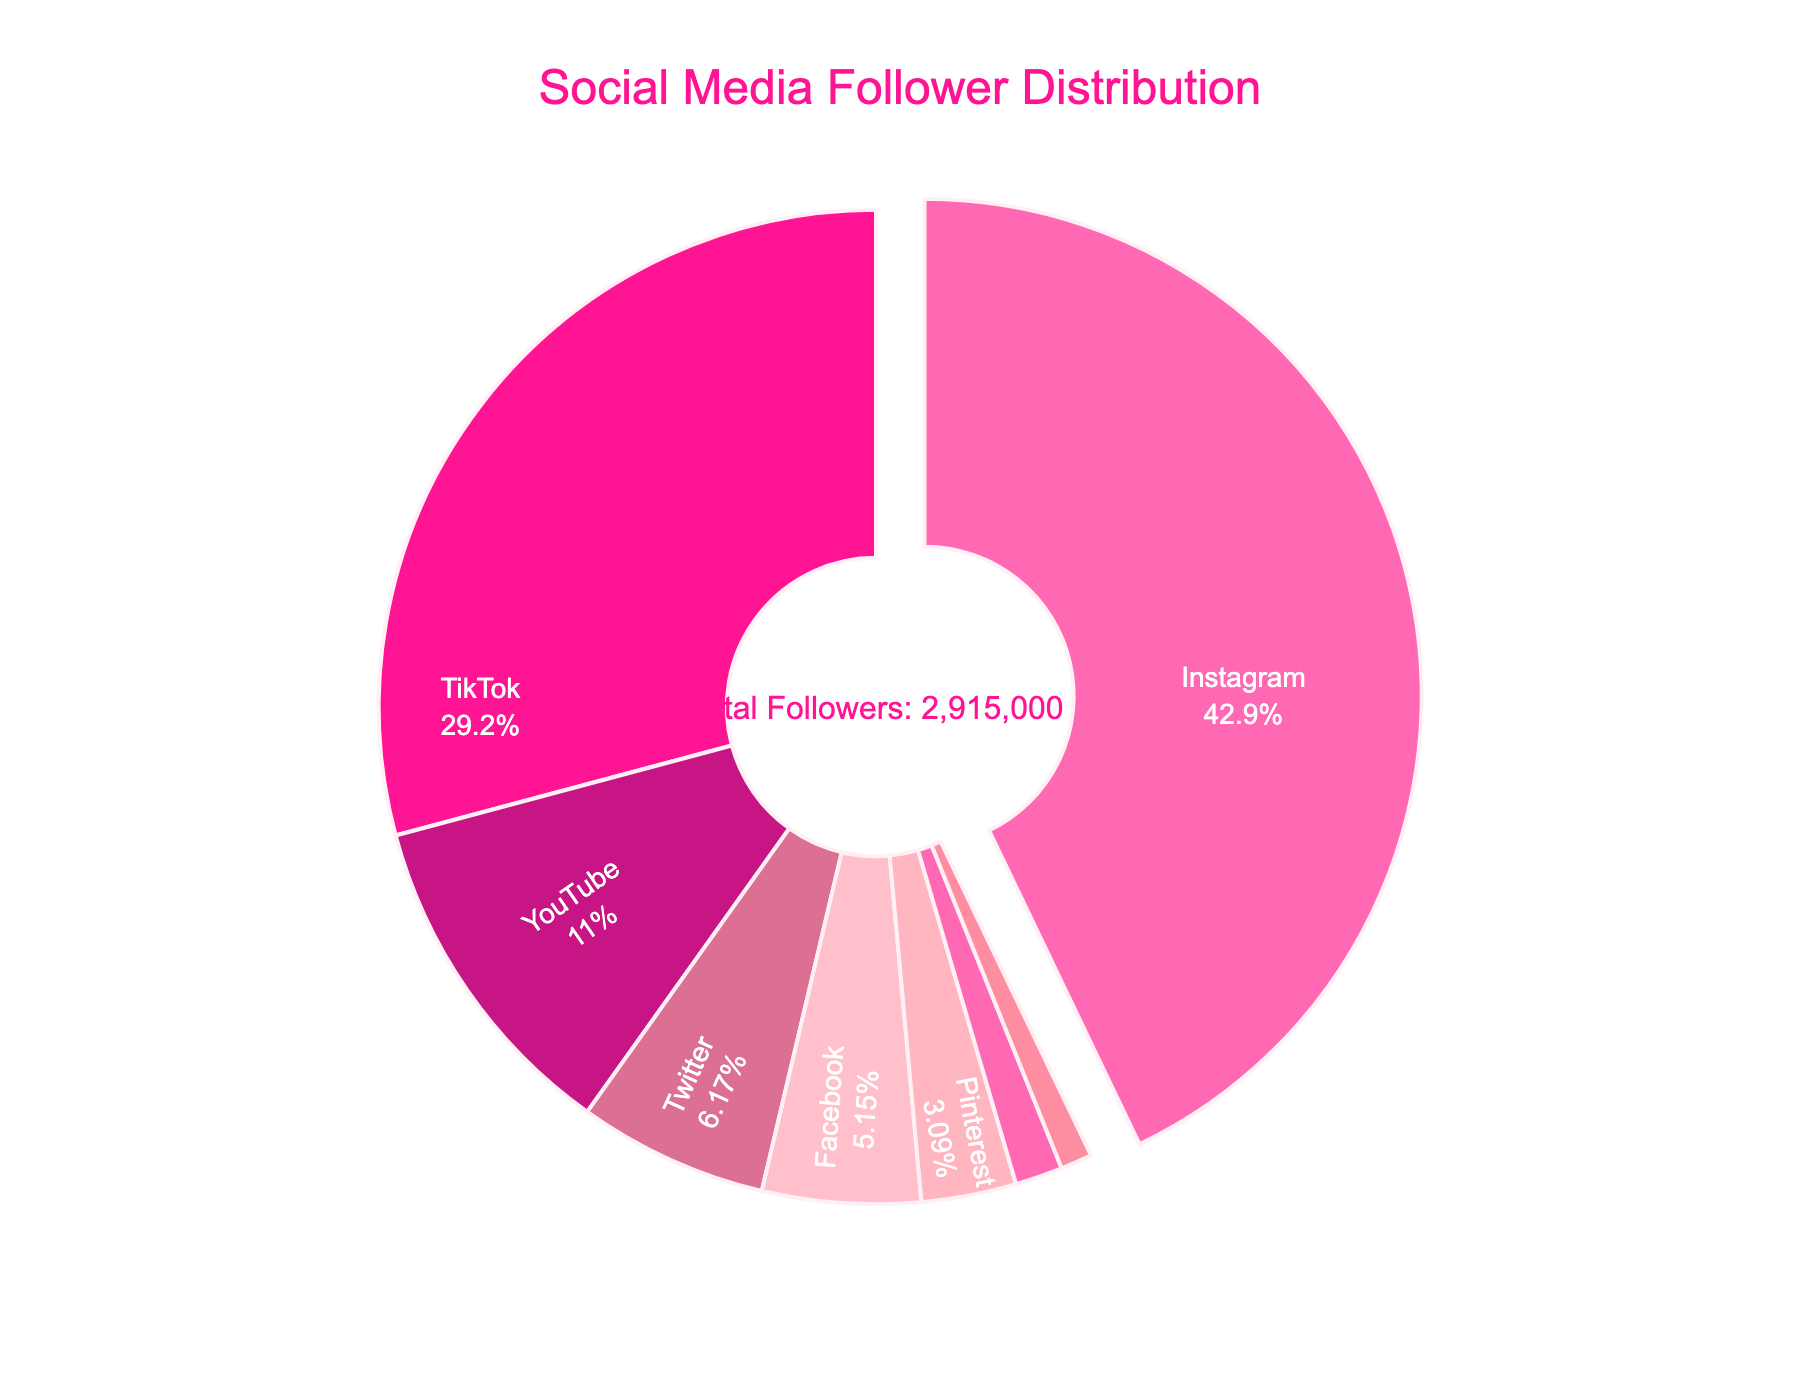Which platform has the largest share of followers? Look at the pie chart to identify the platform with the largest slice. Instagram has the largest slice.
Answer: Instagram Which platform has the smallest share of followers? Look at the pie chart to identify the platform with the smallest slice. Snapchat has the smallest slice.
Answer: Snapchat What percentage of followers are on YouTube? Check the label that indicates the percentage of followers for YouTube in the pie chart.
Answer: 11% Which two platforms combined have the highest percentage of followers? Identify the two platforms with the largest slices and add their percentages together. Instagram (52%) and TikTok (35%) together have 87%.
Answer: Instagram and TikTok How does the number of followers on Pinterest compare to LinkedIn? Refer to the pie chart to compare the sizes of the slices representing Pinterest and LinkedIn. Pinterest has a larger slice than LinkedIn.
Answer: Pinterest has more What's the sum of followers for YouTube, Twitter, and Facebook? Sum up the number of followers for YouTube (320,000), Twitter (180,000), and Facebook (150,000). 320,000 + 180,000 + 150,000 = 650,000
Answer: 650,000 Which platform has roughly one-third the number of followers as TikTok? Compare the slices and percentages. YouTube's percentage is close to one-third of TikTok's percentage.
Answer: YouTube What is the difference in percentage of followers between Instagram and TikTok? Subtract the percentage of followers of TikTok from that of Instagram. 52% - 35% = 17%
Answer: 17% Which platforms have a less than 10% share of followers each? Identify which slices are labeled with percentages lower than 10%. Twitter, Facebook, Pinterest, LinkedIn, and Snapchat all have less than 10% each.
Answer: Twitter, Facebook, Pinterest, LinkedIn, Snapchat What is the average percentage of followers per platform for the smallest four platforms? Sum the percentages of the smallest four platforms (LinkedIn, Snapchat, Pinterest, Facebook) and divide by 4. (2% + 2% + 4% + 6%) / 4 = 3.5%
Answer: 3.5% 